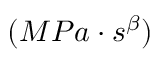Convert formula to latex. <formula><loc_0><loc_0><loc_500><loc_500>( M P a \cdot s ^ { \beta } )</formula> 